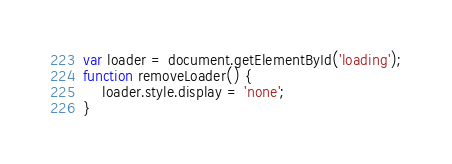<code> <loc_0><loc_0><loc_500><loc_500><_JavaScript_>var loader = document.getElementById('loading');
function removeLoader() {
    loader.style.display = 'none';
}</code> 